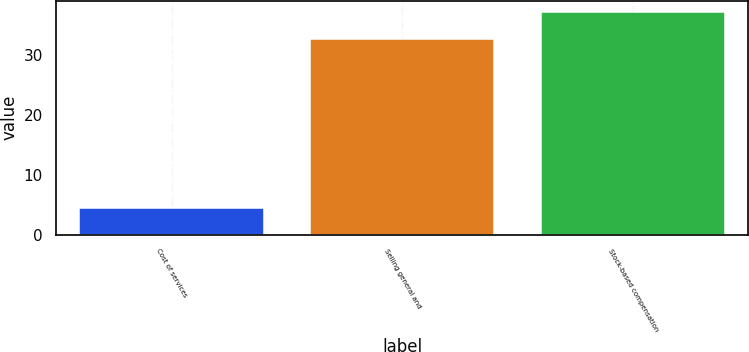Convert chart to OTSL. <chart><loc_0><loc_0><loc_500><loc_500><bar_chart><fcel>Cost of services<fcel>Selling general and<fcel>Stock-based compensation<nl><fcel>4.5<fcel>32.6<fcel>37.1<nl></chart> 